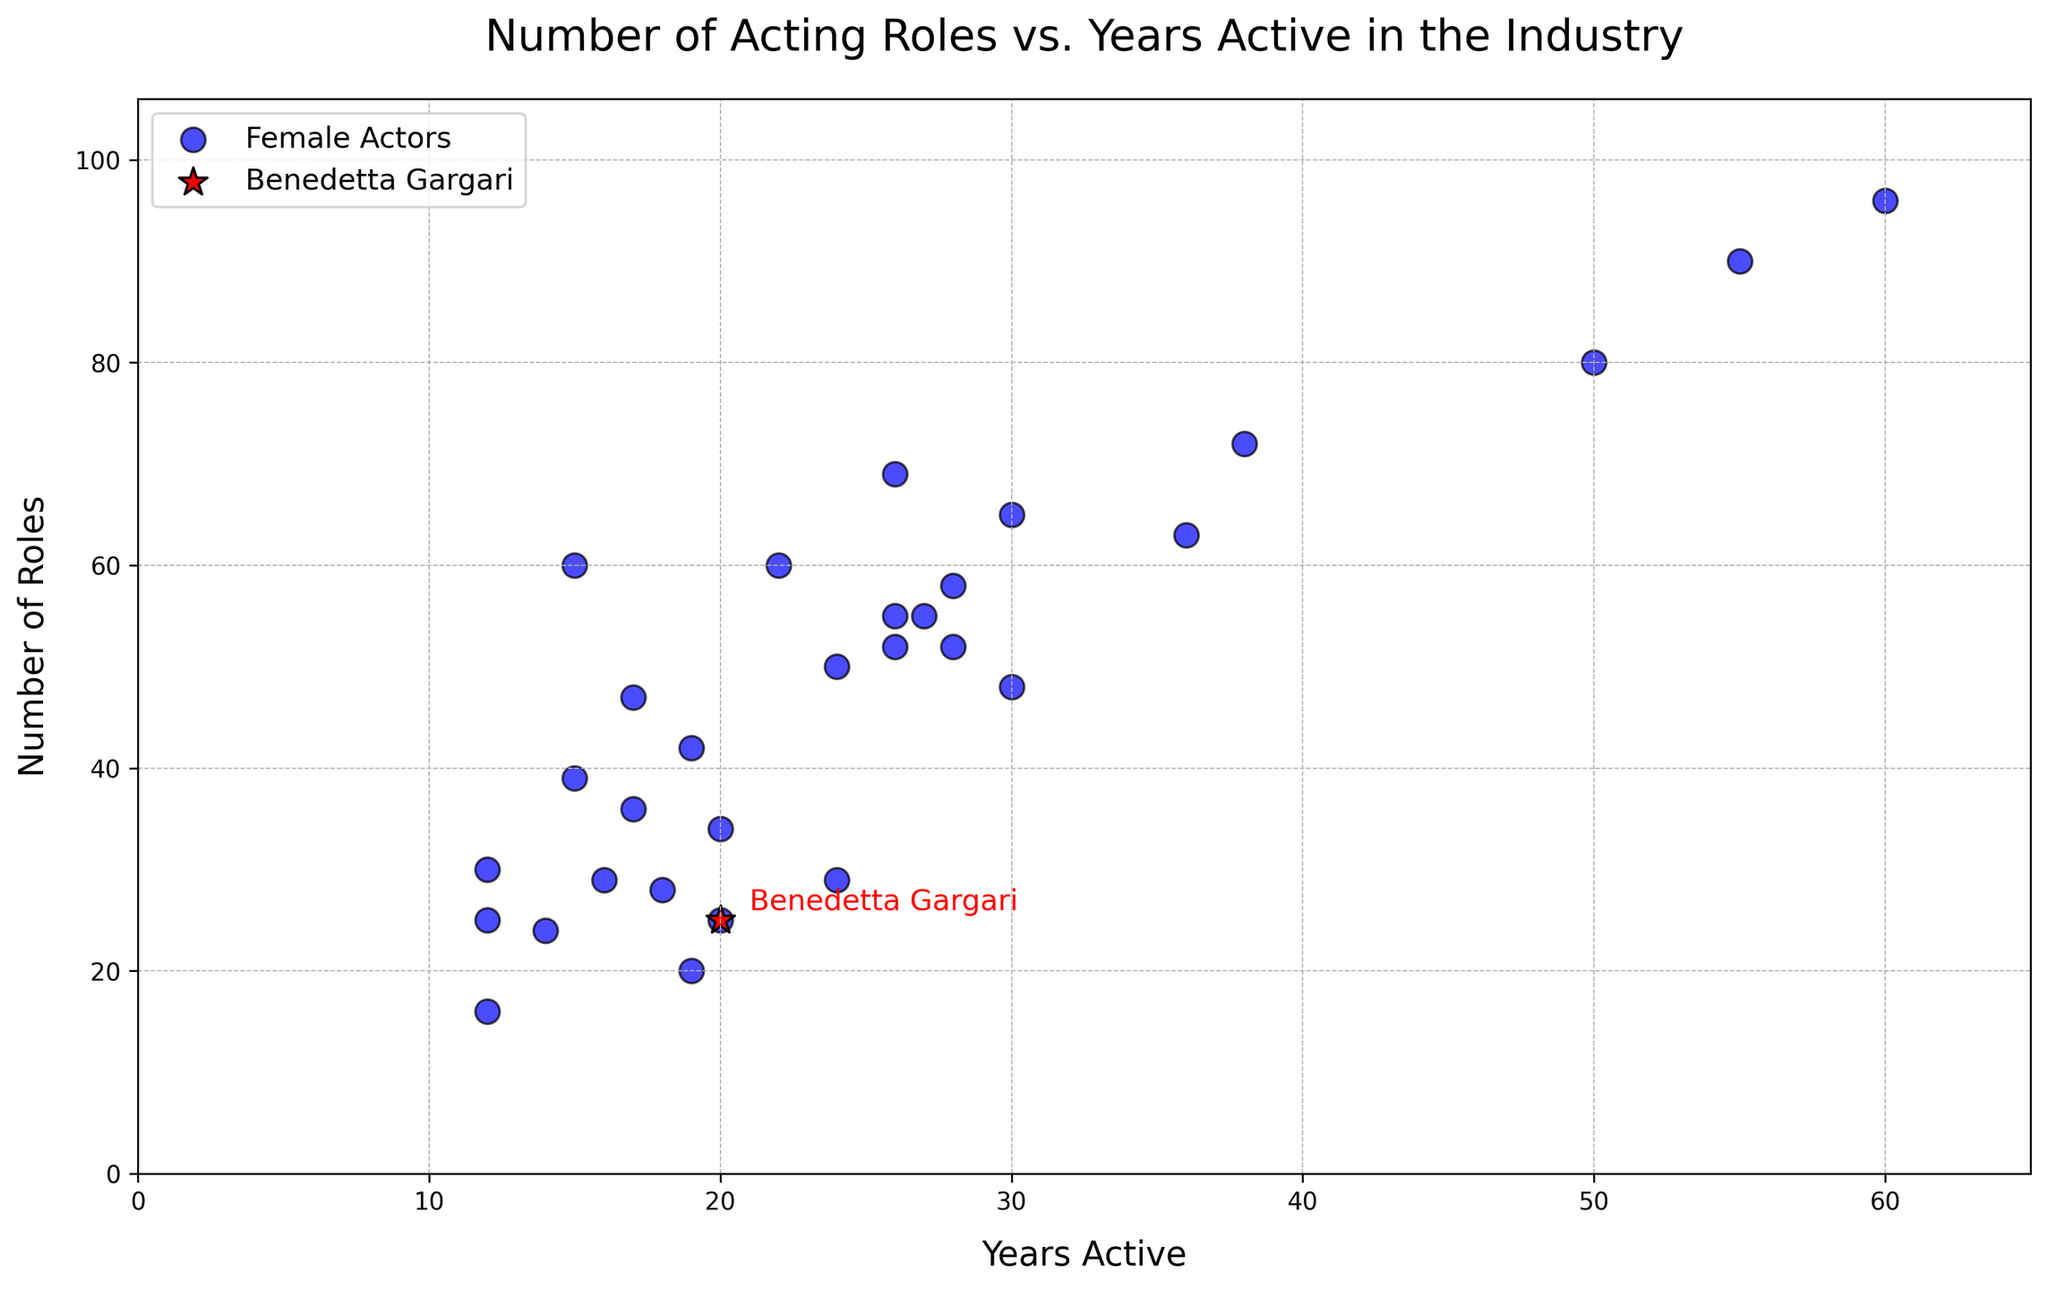how many years has the actress with the most acting roles been active? The actress with the most acting roles should be identified first, followed by checking the number of years she has been active. Jane Fonda has the highest number of acting roles at 96 and has been active for 60 years.
Answer: 60 How many roles has Benedetta Gargari taken compared to an actress with similar years active? Look for an actress with similar years active to Benedetta Gargari (20 years) and compare the number of roles. Emily Blunt (20 years) has 34 roles, while Benedetta has 25 roles.
Answer: 25 vs. 34 Which actress had the steepest increase in roles over the years? Check the incline of the scatter points to see which actress has the steepest slope. Jane Fonda, with 96 roles over 60 years, indicates a high rate of roles per year.
Answer: Jane Fonda What is the average number of roles for actresses who were active for 20 years? Find the actresses active for 20 years and average their roles. Emily Blunt (34 roles) and Benedetta Gargari (25 roles) average to (34+25)/2=29.5.
Answer: 29.5 Who has been active for the longest time? Identify the actor with the highest 'Years Active.' Jane Fonda has been active for the longest time, 60 years.
Answer: Jane Fonda How does the number of years active correlate with the number of roles? Examine the general trend of the scatter plot. There seems to be a positive correlation where more years active generally results in more roles.
Answer: Positive correlation Who has more roles, Charlize Theron or Reese Witherspoon? Check and compare the specific data points for Charlize Theron and Reese Witherspoon. Charlize Theron has 55 roles while Reese Witherspoon has 65 roles.
Answer: Reese Witherspoon Is there any actress with more acting roles than years active? Compare the number of roles with years active for all actresses. All actresses have more roles than years active, often significantly more.
Answer: Yes How many actresses have been active for less than 15 years but have more than 20 roles? Filter the actresses by those who have been active for less than 15 years and then check if they have more than 20 roles. Zendaya (12 years, 25 roles) and Elle Fanning (15 years, 60 roles) meet the criteria.
Answer: 2 Which actress has a similar number of roles to Scarlette Johansson but fewer years active? Look for actresses with fewer years active than 28 but with roles close to Scarlette Johansson's 58 roles. Elle Fanning has 60 roles in 15 years.
Answer: Elle Fanning 